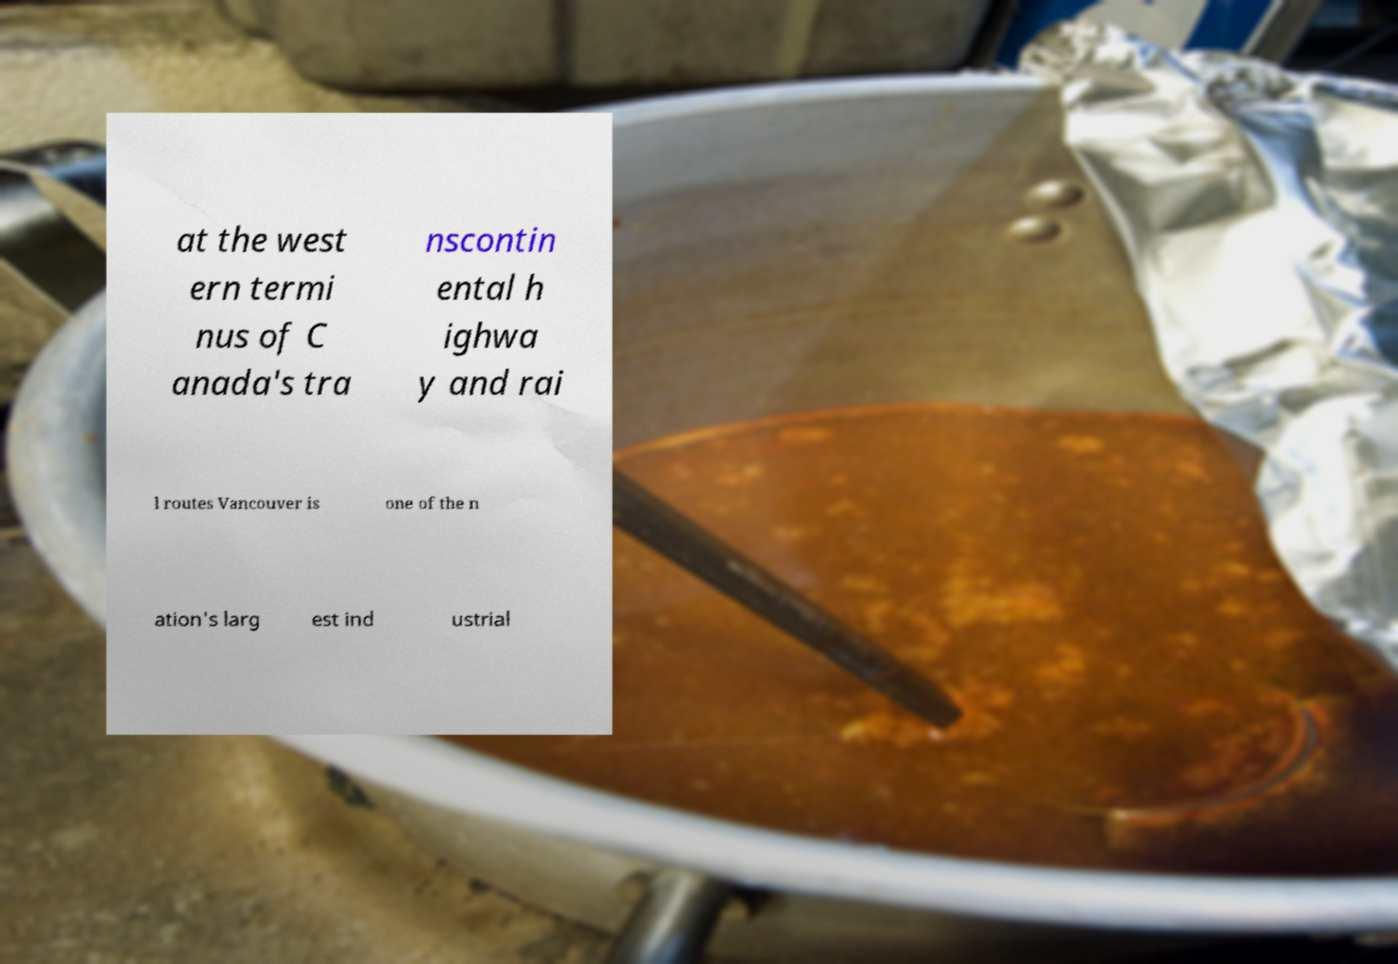I need the written content from this picture converted into text. Can you do that? at the west ern termi nus of C anada's tra nscontin ental h ighwa y and rai l routes Vancouver is one of the n ation's larg est ind ustrial 